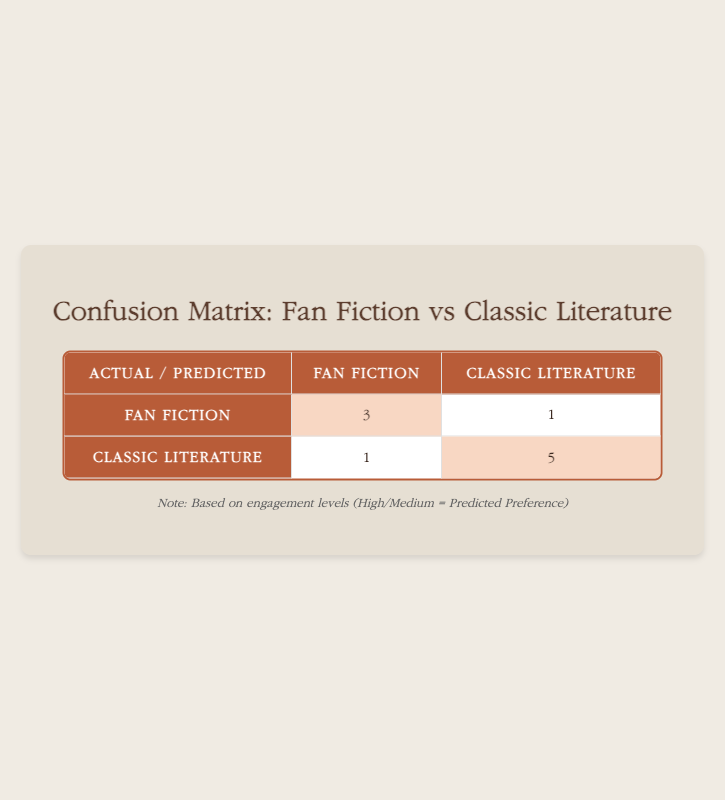What is the count of students who preferred fan fiction? In the table, under the "Fan Fiction" row, the value is 3. This indicates that 3 students preferred fan fiction based on their engagement levels.
Answer: 3 How many students showed a preference for classic literature? In the table, under the "Classic Literature" row, the value is 5. This tells us that 5 students preferred classic literature according to their engagement levels.
Answer: 5 What is the total number of students represented in the confusion matrix? To find the total, we need to add the values from both rows and columns: 3 (Fan Fiction) + 1 (Fan Fiction) + 1 (Classic Literature) + 5 (Classic Literature) = 10. Therefore, there are 10 students in total.
Answer: 10 What percentage of students predicted to prefer fan fiction were actually engaged highly? There are 3 students who were predicted to prefer fan fiction; out of these, 3 had high engagement. The percentage is (3/3) * 100 = 100%. Therefore, 100% of the students who preferred fan fiction were highly engaged.
Answer: 100% Is it true that more students preferred classic literature over fan fiction? Yes, in the table, the number of students preferring classic literature is 5, while the number preferring fan fiction is 3. Comparing these values, classic literature is indeed preferred by more students.
Answer: Yes How many students were incorrectly predicted to prefer fan fiction based on their actual preferences? The matrix shows that 1 student who preferred classic literature was incorrectly predicted to prefer fan fiction, as indicated in the table under the row for classic literature and the column for fan fiction.
Answer: 1 What was the difference in the number of students that preferred classic literature and those that preferred fan fiction with low engagement? There was 1 student who preferred fan fiction with low engagement, and 1 student who preferred classic literature with low engagement. The difference is 1 - 1 = 0. Thus, there is no difference in low engagement preferences between the two groups.
Answer: 0 What is the combined total of students with medium engagement levels across both preferences? For fan fiction, there are 2 students with medium engagement levels, and for classic literature, there are also 2 students. Adding these gives 2 + 2 = 4. Therefore, the total number of medium engagement students is 4.
Answer: 4 What were the engagement levels of the students who preferred fan fiction? 3 students had high engagement, 2 had medium engagement, and 1 had low engagement. This gives us a total of 6 students' engagement levels that can be summarized as: high (3), medium (2), low (1).
Answer: high (3), medium (2), low (1) 